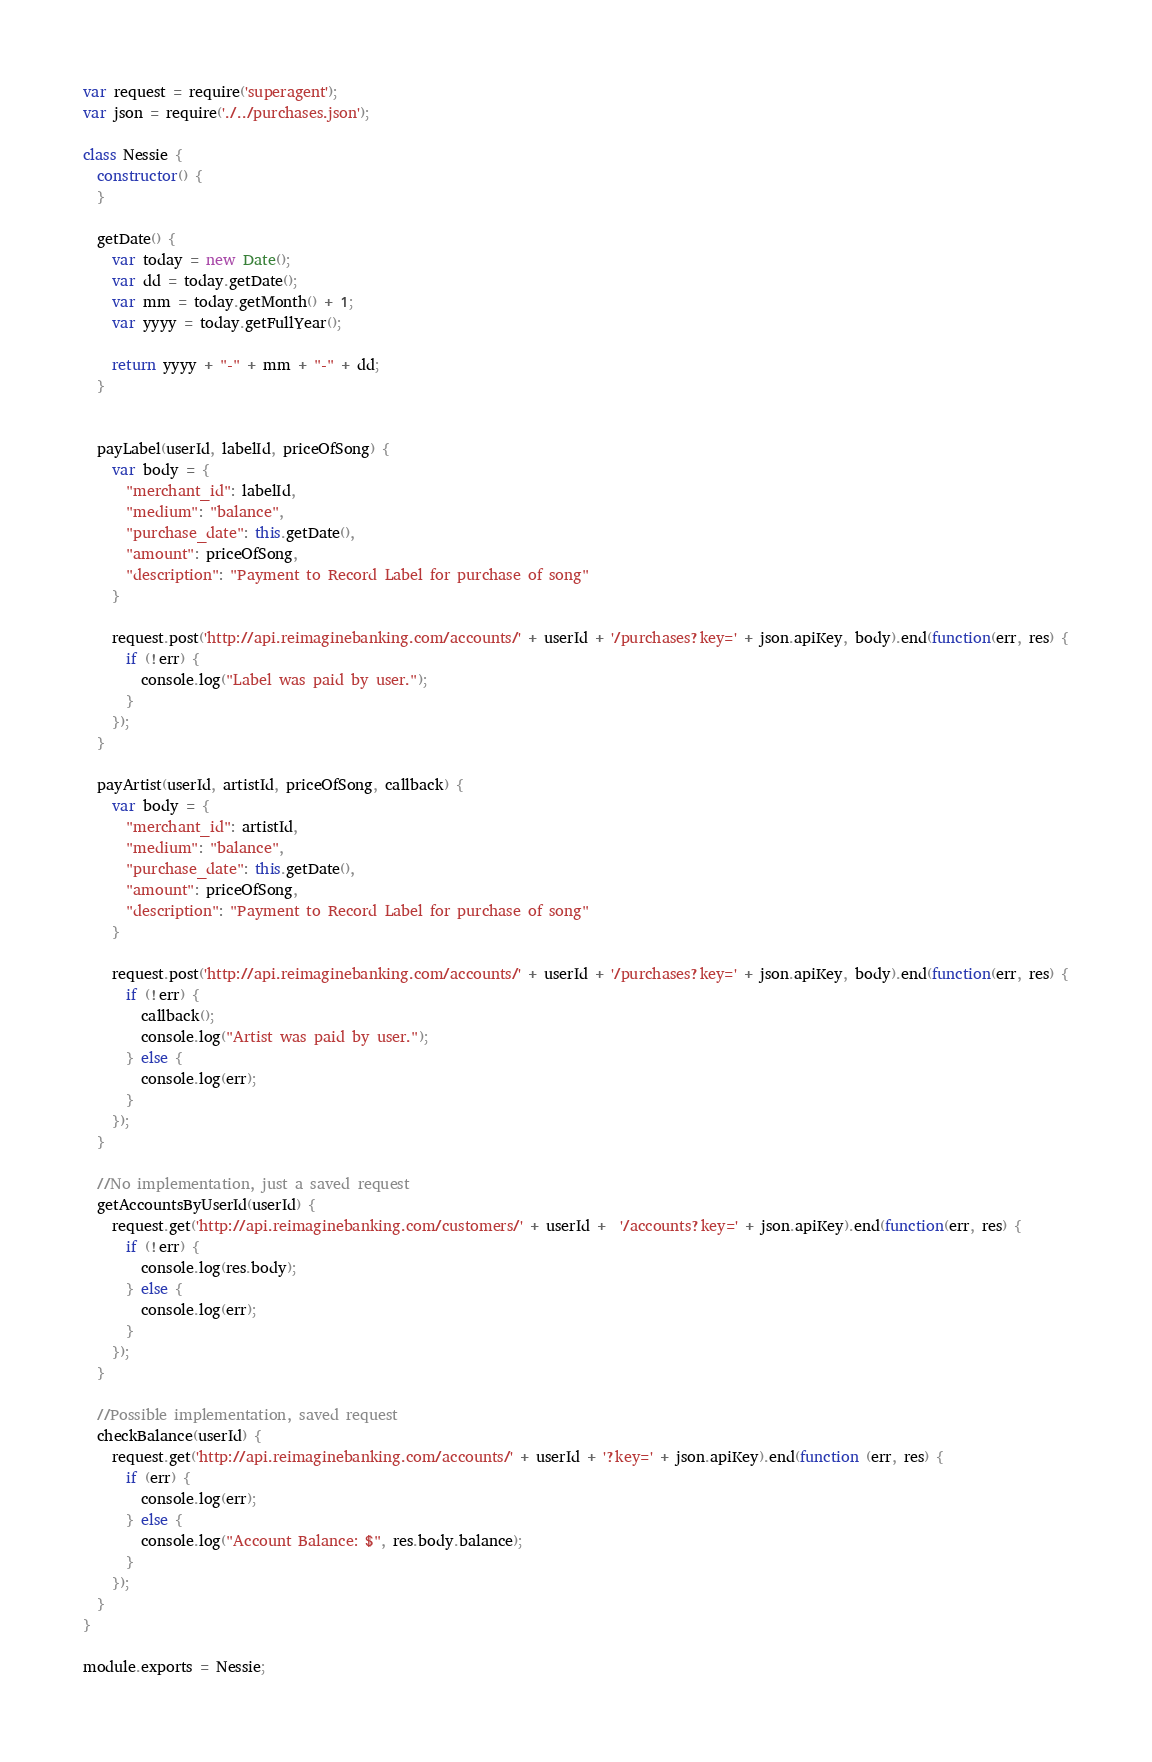Convert code to text. <code><loc_0><loc_0><loc_500><loc_500><_JavaScript_>var request = require('superagent');
var json = require('./../purchases.json');

class Nessie {
  constructor() {
  }

  getDate() {
    var today = new Date();
    var dd = today.getDate();
    var mm = today.getMonth() + 1;
    var yyyy = today.getFullYear();

    return yyyy + "-" + mm + "-" + dd;
  }


  payLabel(userId, labelId, priceOfSong) {
    var body = {
      "merchant_id": labelId,
      "medium": "balance",
      "purchase_date": this.getDate(),
      "amount": priceOfSong,
      "description": "Payment to Record Label for purchase of song"
    }

    request.post('http://api.reimaginebanking.com/accounts/' + userId + '/purchases?key=' + json.apiKey, body).end(function(err, res) {
      if (!err) {
        console.log("Label was paid by user.");
      }
    });
  }

  payArtist(userId, artistId, priceOfSong, callback) {
    var body = {
      "merchant_id": artistId,
      "medium": "balance",
      "purchase_date": this.getDate(),
      "amount": priceOfSong,
      "description": "Payment to Record Label for purchase of song"
    }

    request.post('http://api.reimaginebanking.com/accounts/' + userId + '/purchases?key=' + json.apiKey, body).end(function(err, res) {
      if (!err) {
        callback();
        console.log("Artist was paid by user.");
      } else {
        console.log(err);
      }
    });
  }

  //No implementation, just a saved request
  getAccountsByUserId(userId) {
    request.get('http://api.reimaginebanking.com/customers/' + userId +  '/accounts?key=' + json.apiKey).end(function(err, res) {
      if (!err) {
        console.log(res.body);
      } else {
        console.log(err);
      }
    });
  }

  //Possible implementation, saved request
  checkBalance(userId) {
    request.get('http://api.reimaginebanking.com/accounts/' + userId + '?key=' + json.apiKey).end(function (err, res) {
      if (err) {
        console.log(err);
      } else {
        console.log("Account Balance: $", res.body.balance);
      }
    });
  }
}

module.exports = Nessie;
</code> 